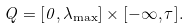Convert formula to latex. <formula><loc_0><loc_0><loc_500><loc_500>Q = [ 0 , \lambda _ { \max } ] \times [ - \infty , \tau ] .</formula> 